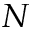<formula> <loc_0><loc_0><loc_500><loc_500>N</formula> 